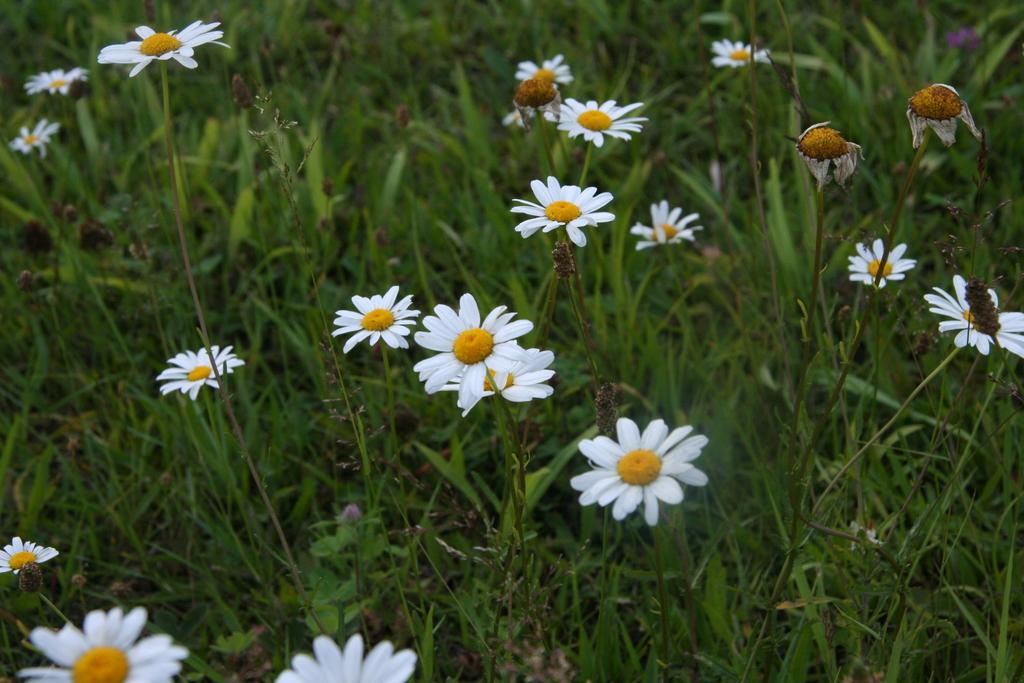What type of vegetation is predominant in the image? There is a lot of grass in the image. Are there any other elements present among the grass? Yes, there are beautiful flowers in between the grass. What type of minister is visible in the image? There is no minister present in the image; it features grass and flowers. What type of drain is visible in the image? There is no drain present in the image; it features grass and flowers. 